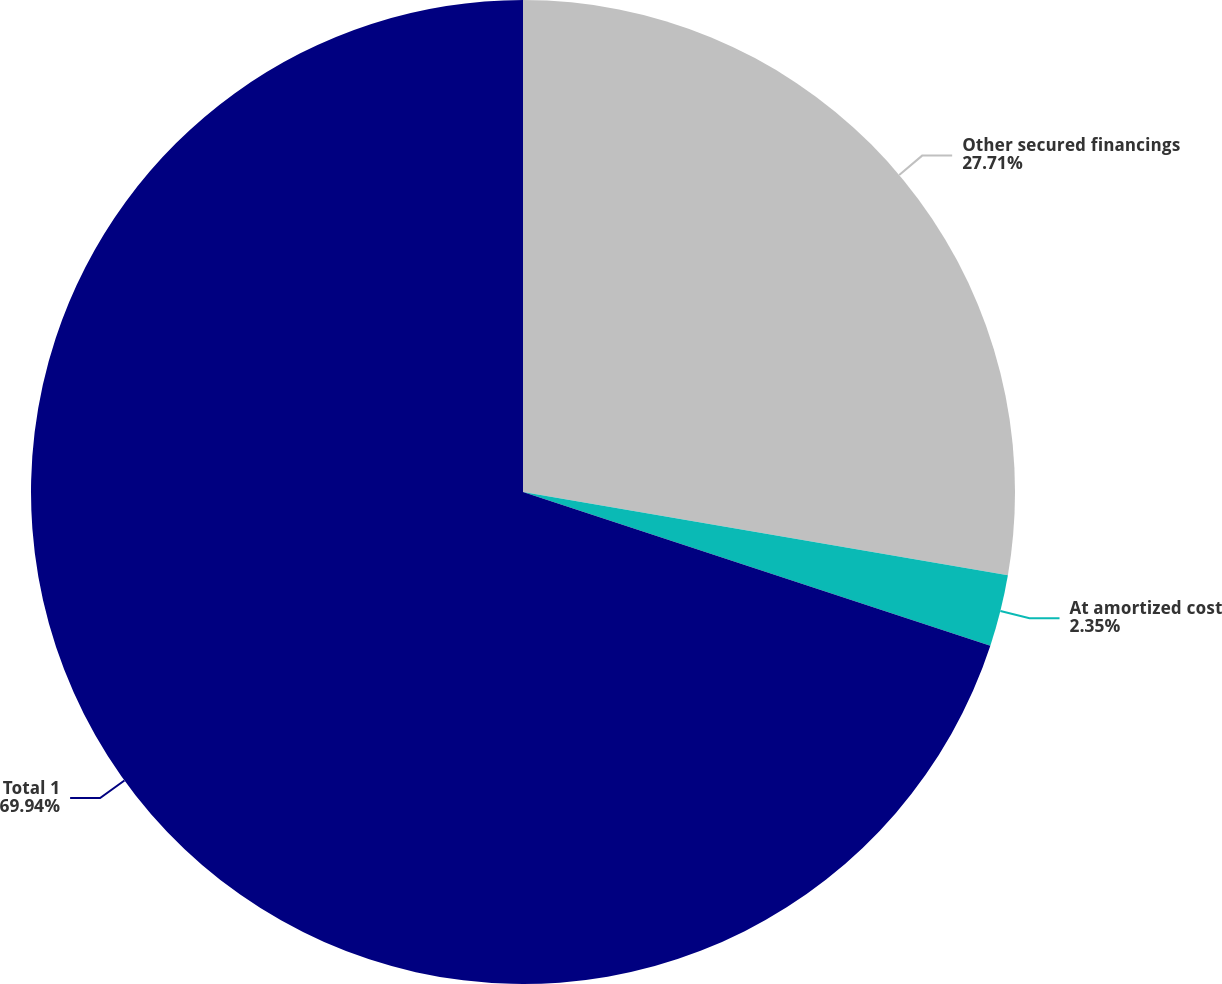<chart> <loc_0><loc_0><loc_500><loc_500><pie_chart><fcel>Other secured financings<fcel>At amortized cost<fcel>Total 1<nl><fcel>27.71%<fcel>2.35%<fcel>69.94%<nl></chart> 